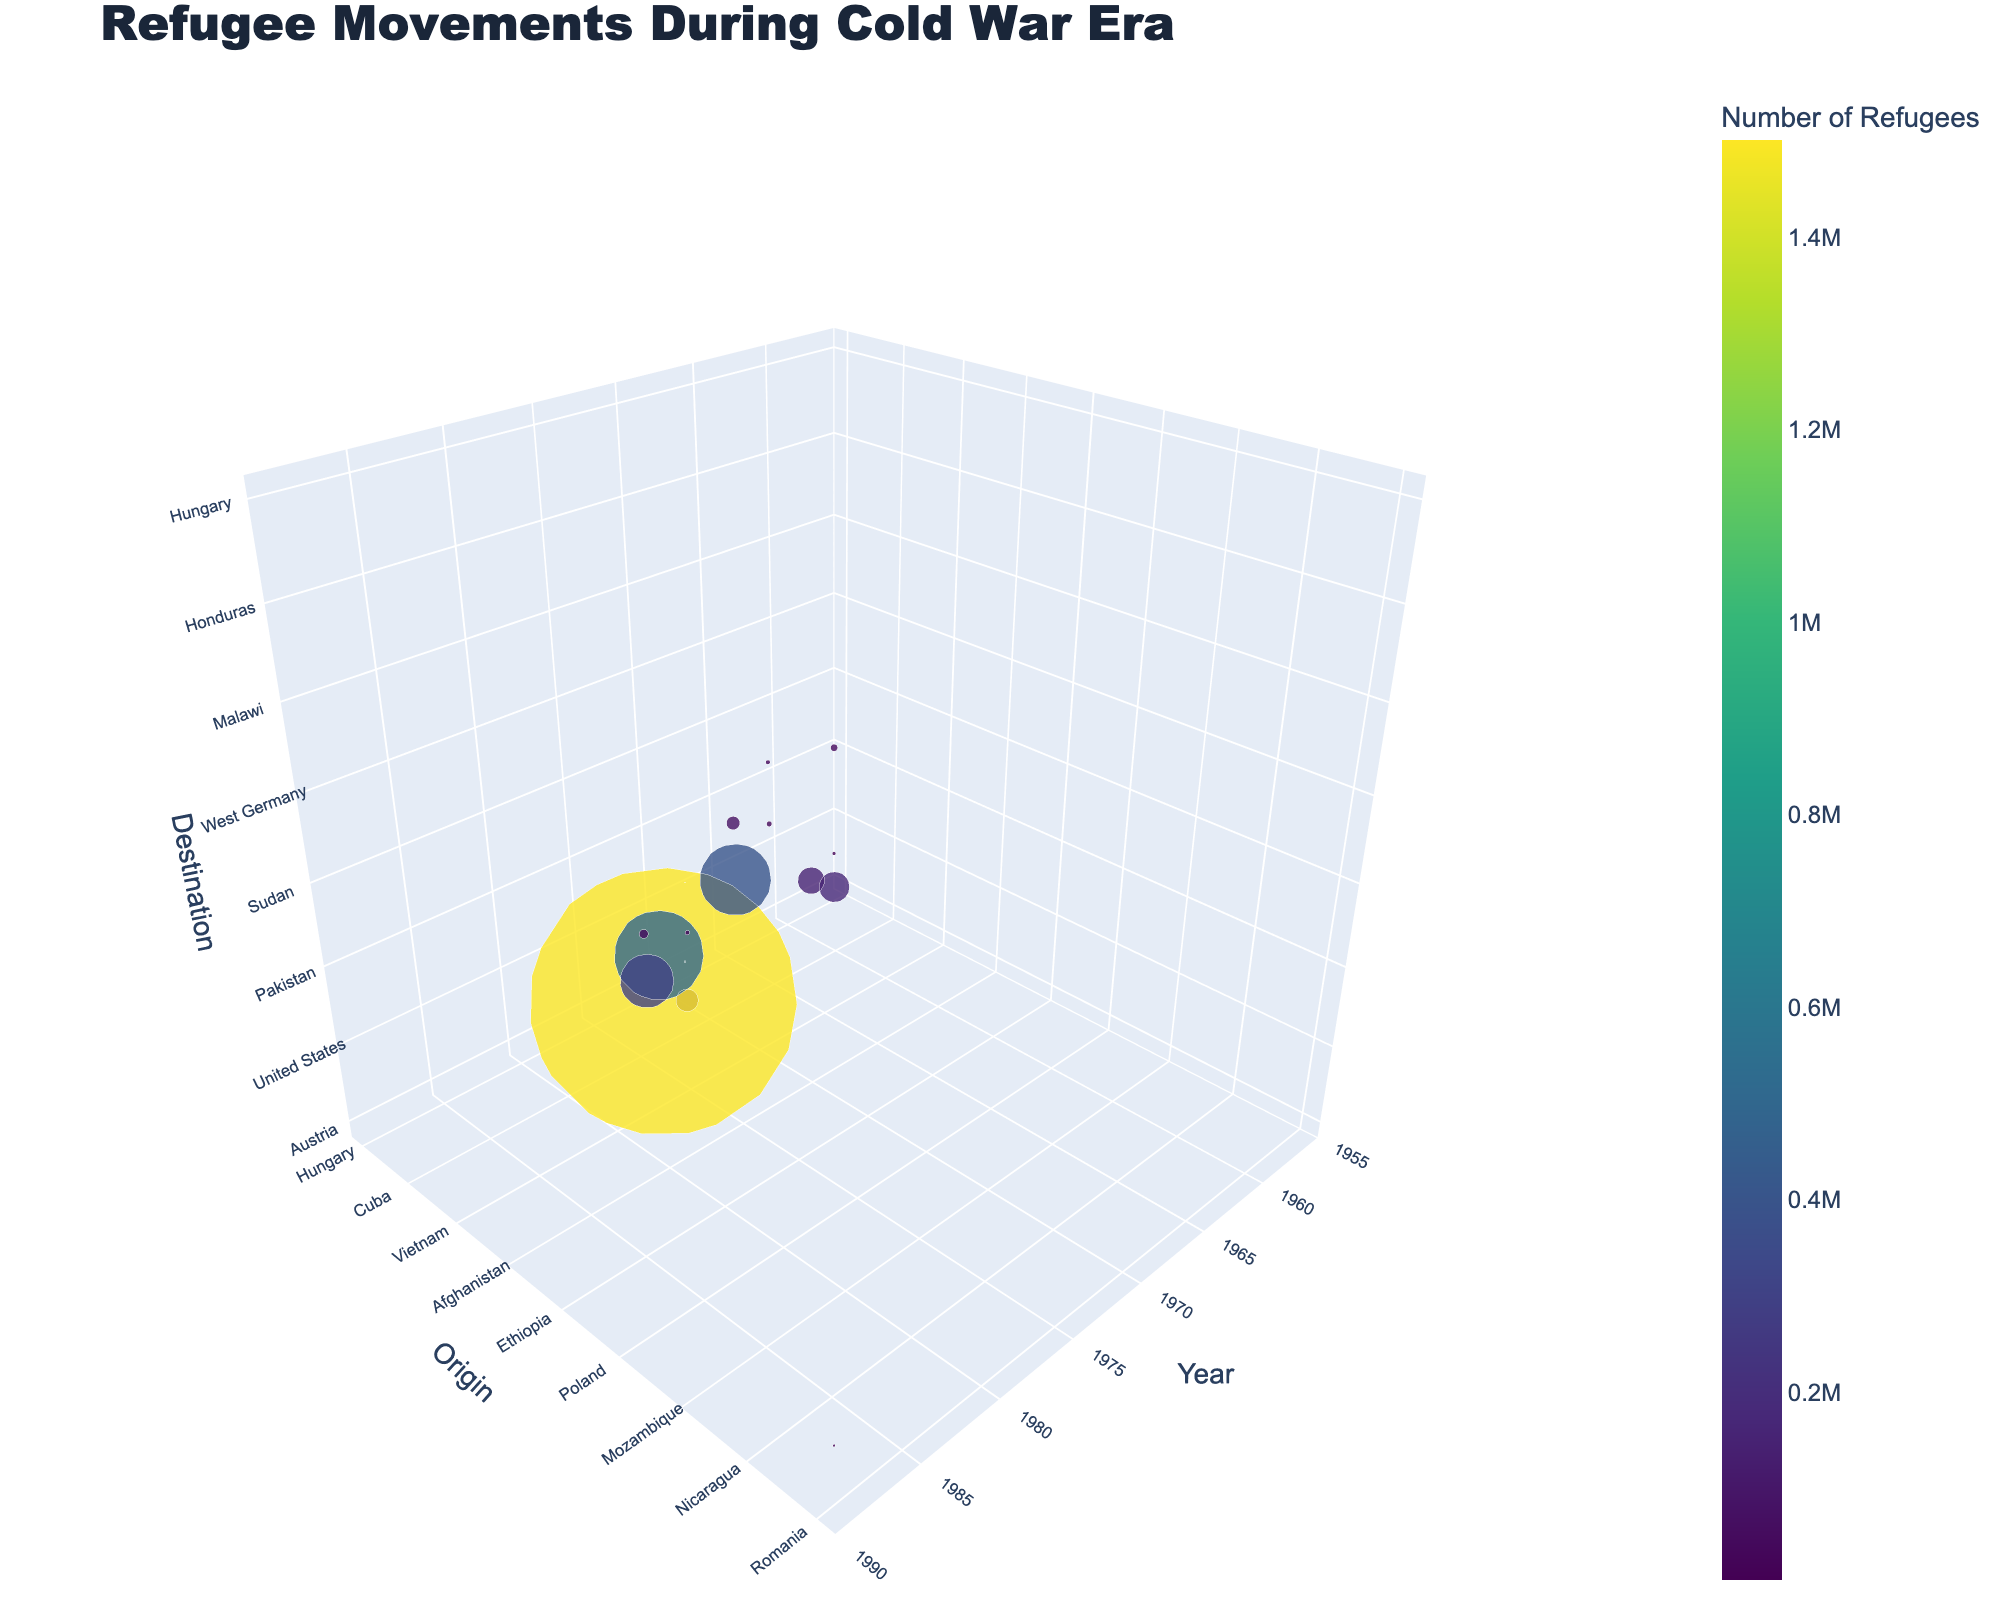How many origin countries are shown in the plot? The y-axis of the plot represents the origin countries. Count the unique countries listed along this axis.
Answer: 8 What is the year range depicted in the plot? Examine the x-axis to find the earliest and latest years displayed. The range starts from the minimum value and ends at the maximum value.
Answer: 1956-1989 Which destination country appears most frequently in the plot? Analyze the z-axis, which shows the destination countries, counting the occurrences of each country to determine which appears most often.
Answer: United States Which refugee movement had the largest number of refugees? The size of the markers indicates the number of refugees. Identify the largest marker and refer to its associated text or hover information to find the exact movement.
Answer: Afghanistan to Pakistan (1980) How many total refugees moved from Hungary in 1956? Find the markers associated with Hungary in the year 1956. Sum the numbers of refugees conveyed by these markers.
Answer: 190,000 What is the most notable refugee movement in the 1960s based on the number of refugees? Look at the markers in the year 1962. Identify the largest marker concerning the year 1962, and read its associated text or hover information to determine the movement.
Answer: Cuba to United States Which two origin countries had significant refugee movements to Iran during the Cold War era? Identify the markers where the destination country is Iran. Note the origin countries for these markers.
Answer: Afghanistan Compare the number of refugees from Vietnam to the United States and France in 1975. Which was greater? Locate the markers representing Vietnamese refugees in 1975. Compare the size (or hover text) of the markers for the United States and France to determine which movement involved more refugees.
Answer: United States In what year did the refugee flow from Mozambique to Malawi occur, and how many refugees were involved? Find the marker for Mozambique with destination Malawi. Access the details provided by the hover text near this marker for the year and the number of refugees.
Answer: 1986, 400,000 Which continent observed the greatest number of refugee movements into multiple other countries during the Cold War era? Summarize movements by continent based on origin countries. Count the number of markers representing each continent and their respective destinations.
Answer: Asia 